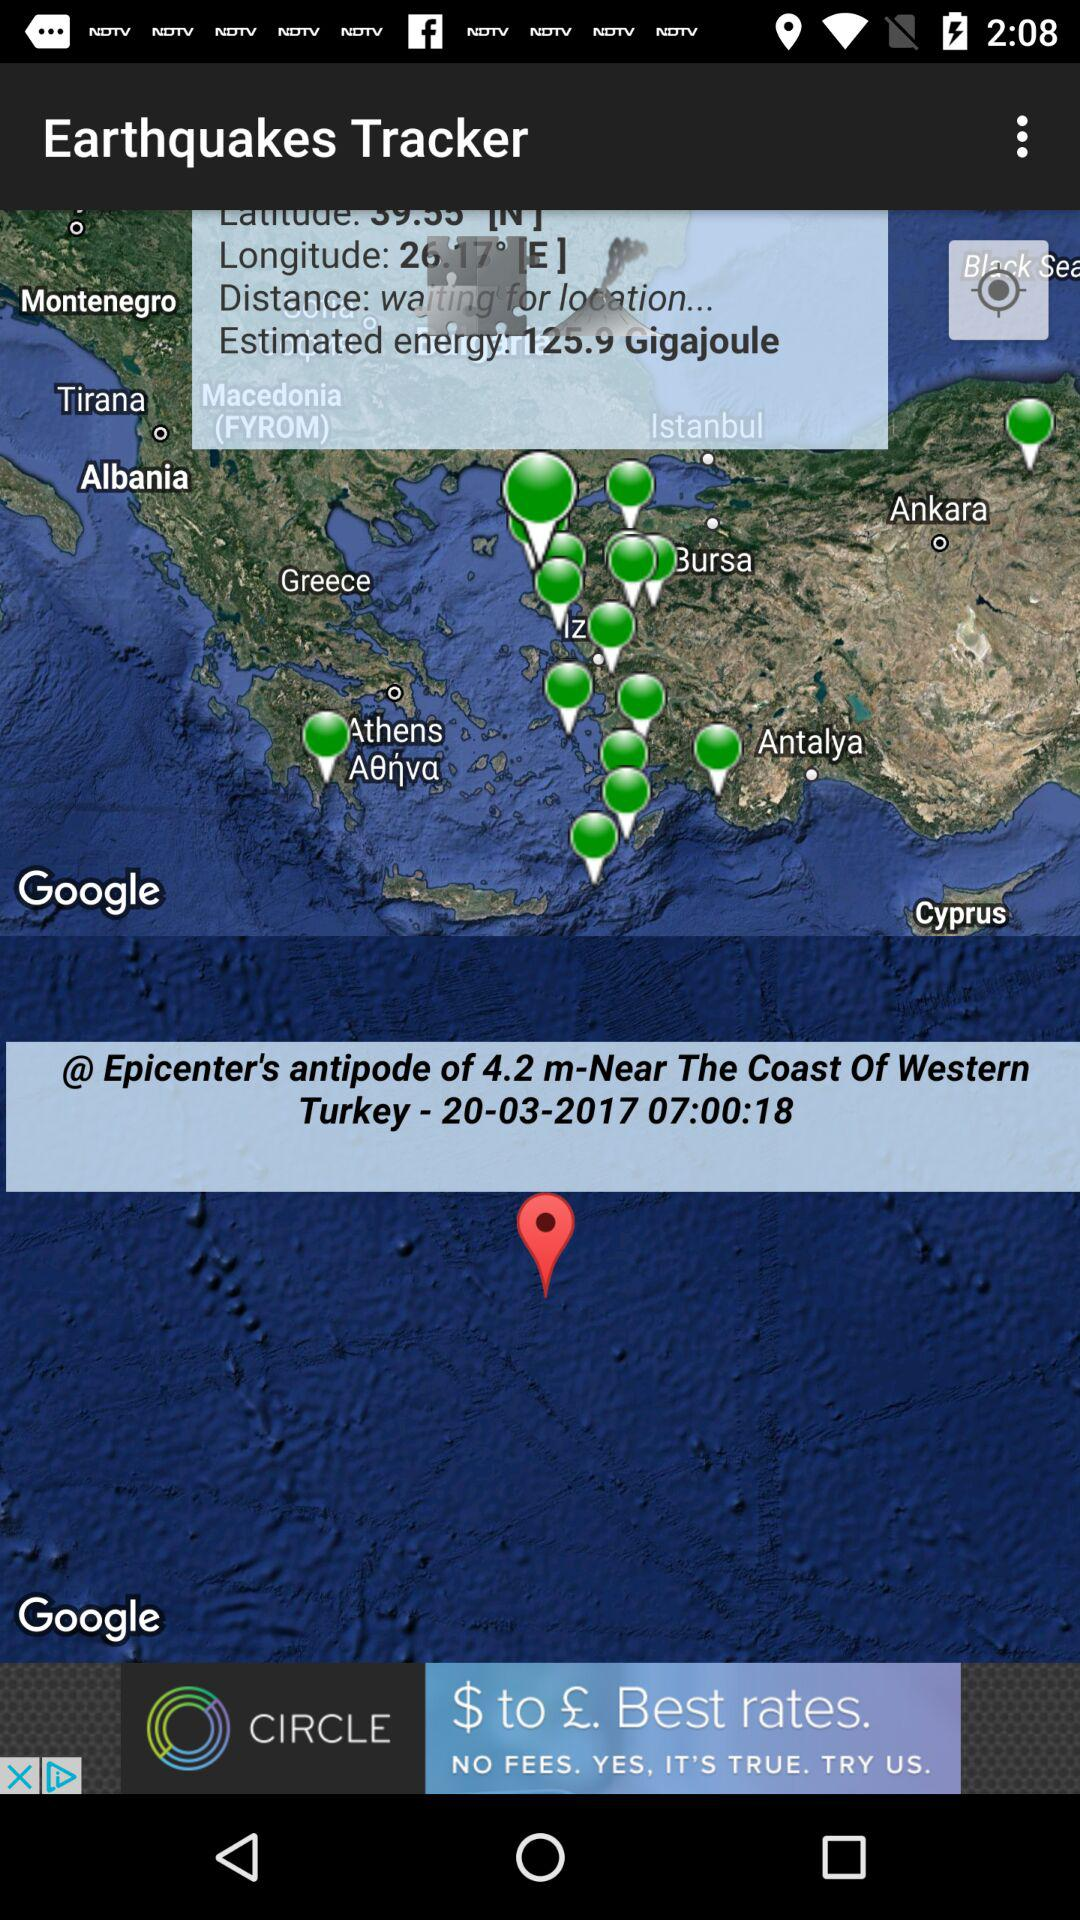What is the estimated energy? It is 125.9 Gigajoule. 